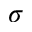<formula> <loc_0><loc_0><loc_500><loc_500>\sigma</formula> 